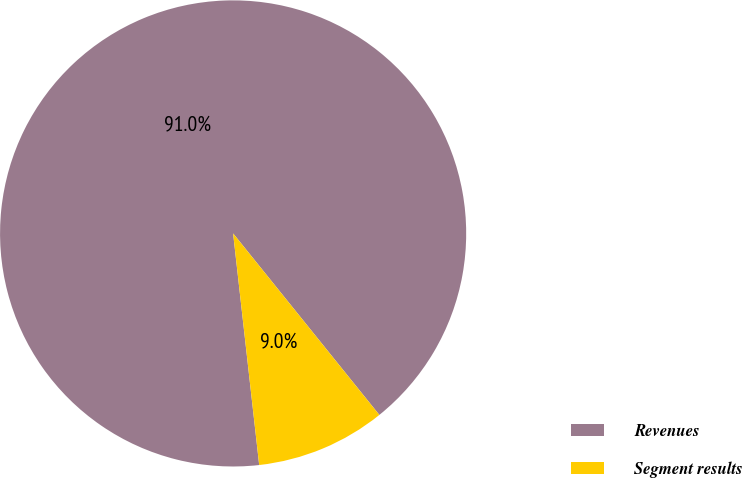Convert chart to OTSL. <chart><loc_0><loc_0><loc_500><loc_500><pie_chart><fcel>Revenues<fcel>Segment results<nl><fcel>90.99%<fcel>9.01%<nl></chart> 